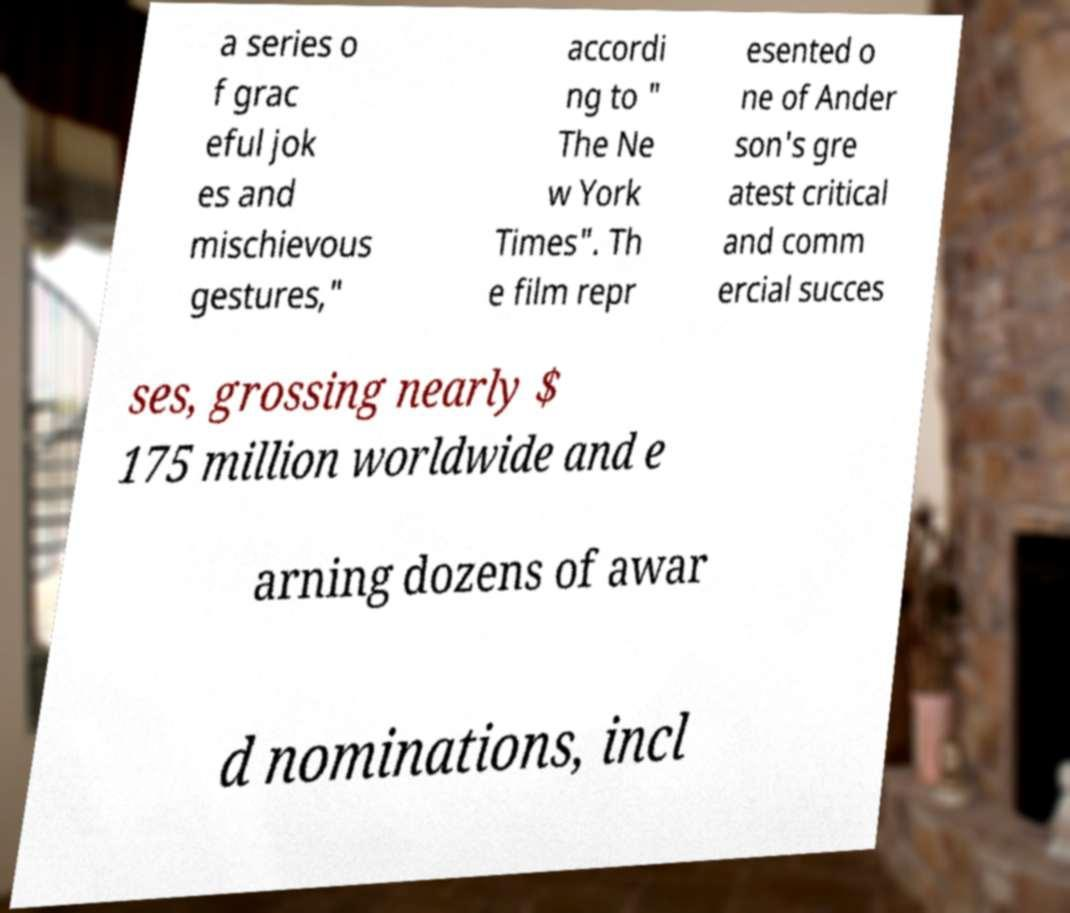What messages or text are displayed in this image? I need them in a readable, typed format. a series o f grac eful jok es and mischievous gestures," accordi ng to " The Ne w York Times". Th e film repr esented o ne of Ander son's gre atest critical and comm ercial succes ses, grossing nearly $ 175 million worldwide and e arning dozens of awar d nominations, incl 